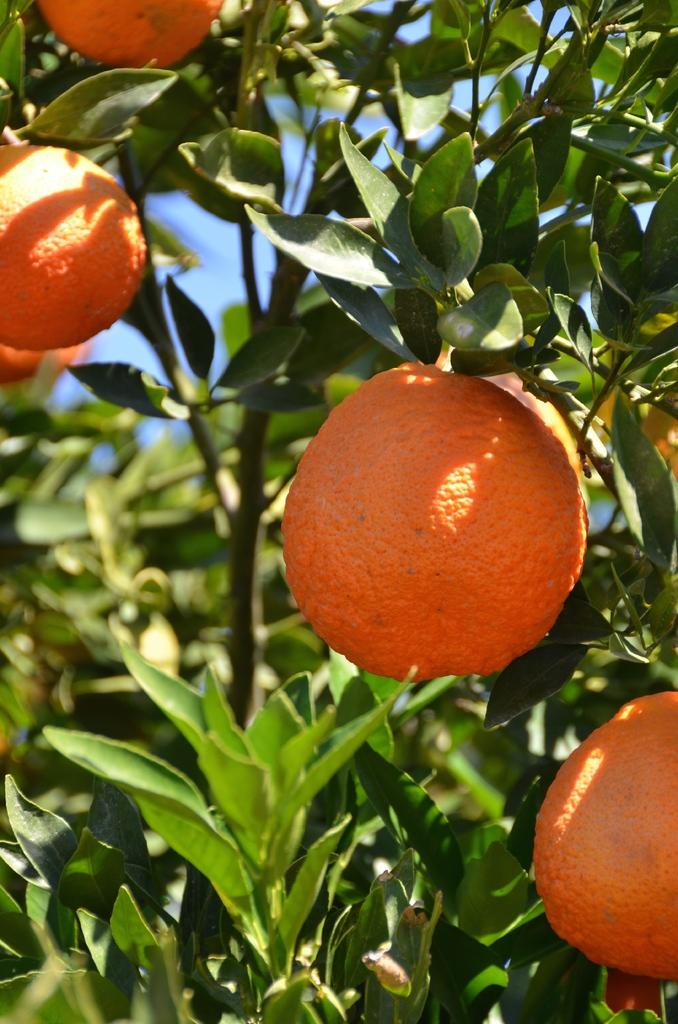What is the main subject of the image? The main subject of the image is a tree. What colors can be seen on the tree? The tree has green and brown colors. What is hanging from the tree? There are fruits on the tree. What color are the fruits? The fruits are orange in color. What can be seen in the background of the image? The sky is visible in the background of the image. What type of texture can be seen on the boot in the image? There is no boot present in the image; it features a tree with fruits. 